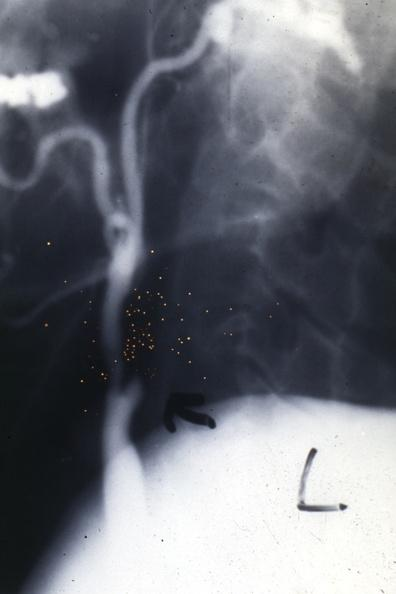where is this from?
Answer the question using a single word or phrase. Aorta 